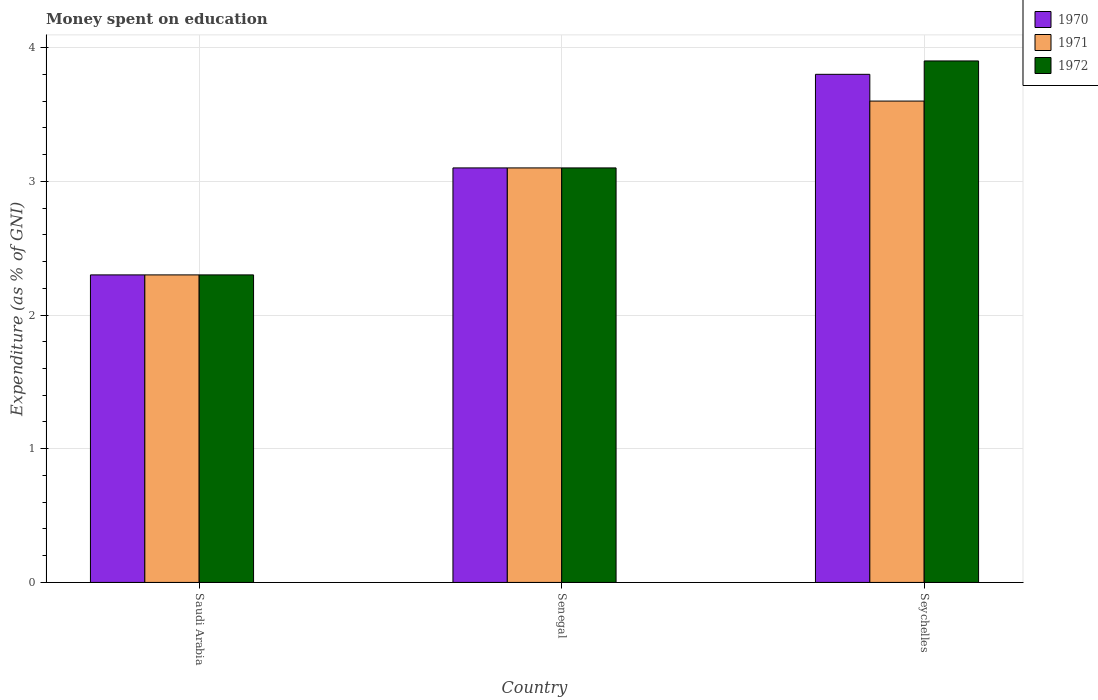How many groups of bars are there?
Provide a succinct answer. 3. Are the number of bars on each tick of the X-axis equal?
Ensure brevity in your answer.  Yes. How many bars are there on the 1st tick from the right?
Your response must be concise. 3. What is the label of the 1st group of bars from the left?
Ensure brevity in your answer.  Saudi Arabia. In how many cases, is the number of bars for a given country not equal to the number of legend labels?
Give a very brief answer. 0. In which country was the amount of money spent on education in 1972 maximum?
Your answer should be compact. Seychelles. In which country was the amount of money spent on education in 1972 minimum?
Ensure brevity in your answer.  Saudi Arabia. What is the total amount of money spent on education in 1971 in the graph?
Provide a succinct answer. 9. What is the difference between the amount of money spent on education in 1971 in Saudi Arabia and that in Seychelles?
Make the answer very short. -1.3. What is the difference between the amount of money spent on education in 1972 in Senegal and the amount of money spent on education in 1970 in Seychelles?
Your answer should be compact. -0.7. What is the difference between the amount of money spent on education of/in 1972 and amount of money spent on education of/in 1970 in Senegal?
Offer a terse response. 0. What is the ratio of the amount of money spent on education in 1970 in Saudi Arabia to that in Senegal?
Give a very brief answer. 0.74. What is the difference between the highest and the second highest amount of money spent on education in 1971?
Your answer should be very brief. 0.8. What is the difference between the highest and the lowest amount of money spent on education in 1972?
Your answer should be very brief. 1.6. In how many countries, is the amount of money spent on education in 1972 greater than the average amount of money spent on education in 1972 taken over all countries?
Your answer should be very brief. 1. Is the sum of the amount of money spent on education in 1972 in Saudi Arabia and Seychelles greater than the maximum amount of money spent on education in 1971 across all countries?
Your response must be concise. Yes. What does the 1st bar from the right in Saudi Arabia represents?
Offer a very short reply. 1972. Is it the case that in every country, the sum of the amount of money spent on education in 1970 and amount of money spent on education in 1971 is greater than the amount of money spent on education in 1972?
Give a very brief answer. Yes. How many countries are there in the graph?
Your answer should be very brief. 3. What is the difference between two consecutive major ticks on the Y-axis?
Your response must be concise. 1. Are the values on the major ticks of Y-axis written in scientific E-notation?
Provide a succinct answer. No. Does the graph contain any zero values?
Offer a very short reply. No. Does the graph contain grids?
Your answer should be very brief. Yes. Where does the legend appear in the graph?
Provide a short and direct response. Top right. How many legend labels are there?
Provide a short and direct response. 3. How are the legend labels stacked?
Offer a terse response. Vertical. What is the title of the graph?
Provide a short and direct response. Money spent on education. What is the label or title of the X-axis?
Ensure brevity in your answer.  Country. What is the label or title of the Y-axis?
Ensure brevity in your answer.  Expenditure (as % of GNI). What is the Expenditure (as % of GNI) in 1972 in Saudi Arabia?
Provide a short and direct response. 2.3. What is the Expenditure (as % of GNI) of 1970 in Senegal?
Your response must be concise. 3.1. What is the Expenditure (as % of GNI) in 1971 in Senegal?
Your response must be concise. 3.1. What is the Expenditure (as % of GNI) of 1972 in Senegal?
Provide a succinct answer. 3.1. What is the Expenditure (as % of GNI) of 1970 in Seychelles?
Ensure brevity in your answer.  3.8. What is the Expenditure (as % of GNI) in 1971 in Seychelles?
Provide a succinct answer. 3.6. Across all countries, what is the maximum Expenditure (as % of GNI) of 1970?
Provide a short and direct response. 3.8. Across all countries, what is the maximum Expenditure (as % of GNI) in 1971?
Ensure brevity in your answer.  3.6. Across all countries, what is the maximum Expenditure (as % of GNI) of 1972?
Provide a short and direct response. 3.9. Across all countries, what is the minimum Expenditure (as % of GNI) in 1970?
Your response must be concise. 2.3. Across all countries, what is the minimum Expenditure (as % of GNI) of 1972?
Provide a succinct answer. 2.3. What is the difference between the Expenditure (as % of GNI) in 1972 in Saudi Arabia and that in Senegal?
Your response must be concise. -0.8. What is the difference between the Expenditure (as % of GNI) of 1972 in Saudi Arabia and that in Seychelles?
Your answer should be compact. -1.6. What is the difference between the Expenditure (as % of GNI) in 1971 in Senegal and that in Seychelles?
Your answer should be very brief. -0.5. What is the difference between the Expenditure (as % of GNI) of 1970 in Saudi Arabia and the Expenditure (as % of GNI) of 1971 in Senegal?
Make the answer very short. -0.8. What is the difference between the Expenditure (as % of GNI) in 1970 in Saudi Arabia and the Expenditure (as % of GNI) in 1971 in Seychelles?
Your answer should be very brief. -1.3. What is the difference between the Expenditure (as % of GNI) of 1970 in Saudi Arabia and the Expenditure (as % of GNI) of 1972 in Seychelles?
Provide a succinct answer. -1.6. What is the difference between the Expenditure (as % of GNI) in 1971 in Saudi Arabia and the Expenditure (as % of GNI) in 1972 in Seychelles?
Your answer should be compact. -1.6. What is the difference between the Expenditure (as % of GNI) in 1970 in Senegal and the Expenditure (as % of GNI) in 1971 in Seychelles?
Your response must be concise. -0.5. What is the average Expenditure (as % of GNI) in 1970 per country?
Offer a very short reply. 3.07. What is the difference between the Expenditure (as % of GNI) in 1970 and Expenditure (as % of GNI) in 1971 in Saudi Arabia?
Offer a terse response. 0. What is the difference between the Expenditure (as % of GNI) in 1971 and Expenditure (as % of GNI) in 1972 in Saudi Arabia?
Keep it short and to the point. 0. What is the difference between the Expenditure (as % of GNI) of 1970 and Expenditure (as % of GNI) of 1972 in Senegal?
Your answer should be compact. 0. What is the difference between the Expenditure (as % of GNI) in 1970 and Expenditure (as % of GNI) in 1972 in Seychelles?
Provide a succinct answer. -0.1. What is the ratio of the Expenditure (as % of GNI) of 1970 in Saudi Arabia to that in Senegal?
Your response must be concise. 0.74. What is the ratio of the Expenditure (as % of GNI) of 1971 in Saudi Arabia to that in Senegal?
Offer a very short reply. 0.74. What is the ratio of the Expenditure (as % of GNI) of 1972 in Saudi Arabia to that in Senegal?
Offer a terse response. 0.74. What is the ratio of the Expenditure (as % of GNI) of 1970 in Saudi Arabia to that in Seychelles?
Keep it short and to the point. 0.61. What is the ratio of the Expenditure (as % of GNI) in 1971 in Saudi Arabia to that in Seychelles?
Offer a very short reply. 0.64. What is the ratio of the Expenditure (as % of GNI) of 1972 in Saudi Arabia to that in Seychelles?
Your response must be concise. 0.59. What is the ratio of the Expenditure (as % of GNI) of 1970 in Senegal to that in Seychelles?
Offer a terse response. 0.82. What is the ratio of the Expenditure (as % of GNI) of 1971 in Senegal to that in Seychelles?
Offer a very short reply. 0.86. What is the ratio of the Expenditure (as % of GNI) of 1972 in Senegal to that in Seychelles?
Offer a very short reply. 0.79. What is the difference between the highest and the second highest Expenditure (as % of GNI) in 1970?
Offer a very short reply. 0.7. What is the difference between the highest and the second highest Expenditure (as % of GNI) in 1972?
Provide a succinct answer. 0.8. What is the difference between the highest and the lowest Expenditure (as % of GNI) of 1971?
Your answer should be compact. 1.3. What is the difference between the highest and the lowest Expenditure (as % of GNI) in 1972?
Give a very brief answer. 1.6. 